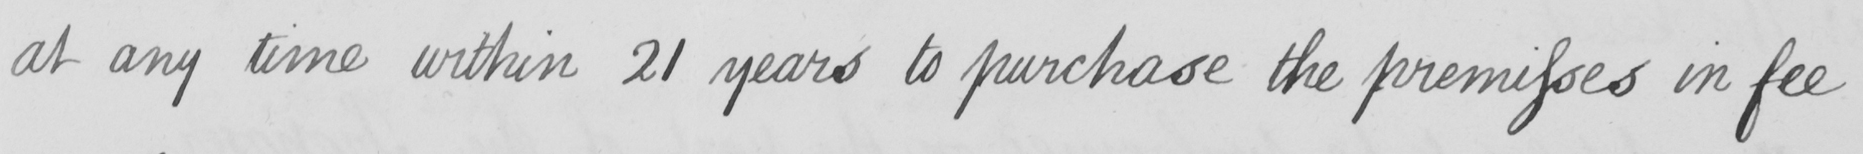What text is written in this handwritten line? at any time within 21 years to purchase the premisses in fee 